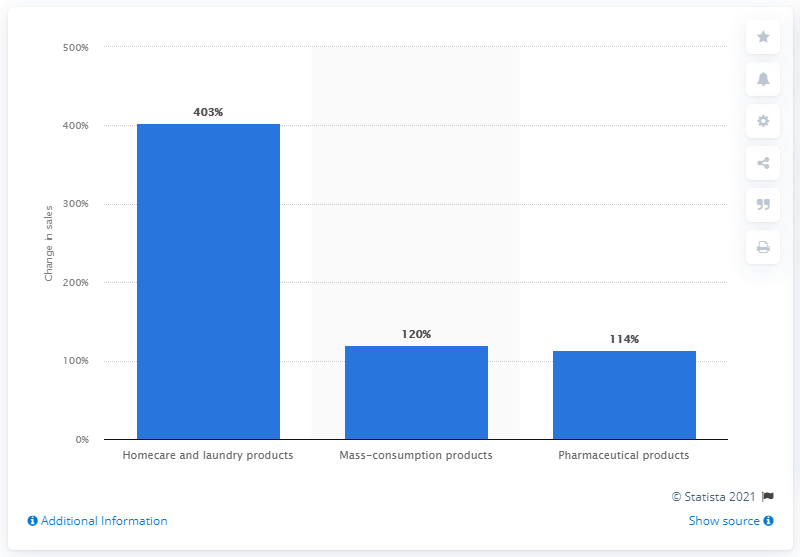List a handful of essential elements in this visual. The production of mass-consumption products and pharmaceuticals increased by 120% in the first quarter of 2023, according to the latest statistics released by the Ministry of Industry and Information Technology. 